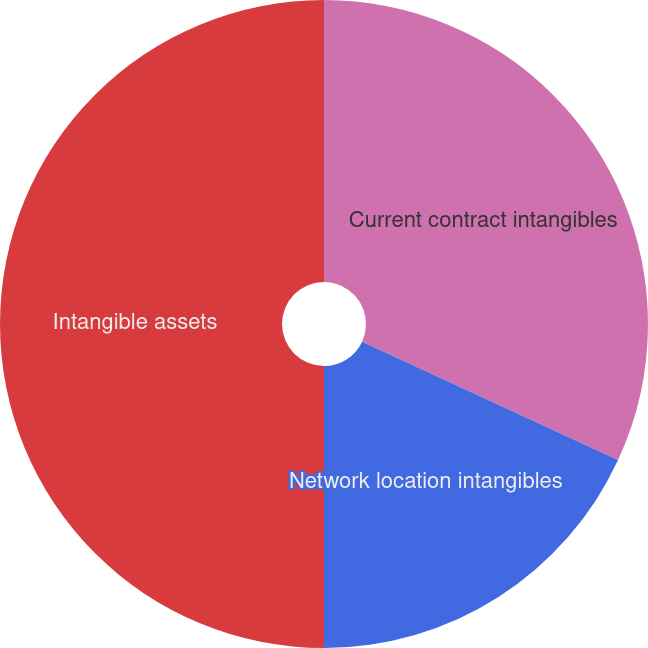<chart> <loc_0><loc_0><loc_500><loc_500><pie_chart><fcel>Current contract intangibles<fcel>Network location intangibles<fcel>Intangible assets<nl><fcel>31.9%<fcel>18.1%<fcel>50.0%<nl></chart> 